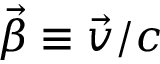Convert formula to latex. <formula><loc_0><loc_0><loc_500><loc_500>\vec { \beta } \equiv \vec { v } / c</formula> 